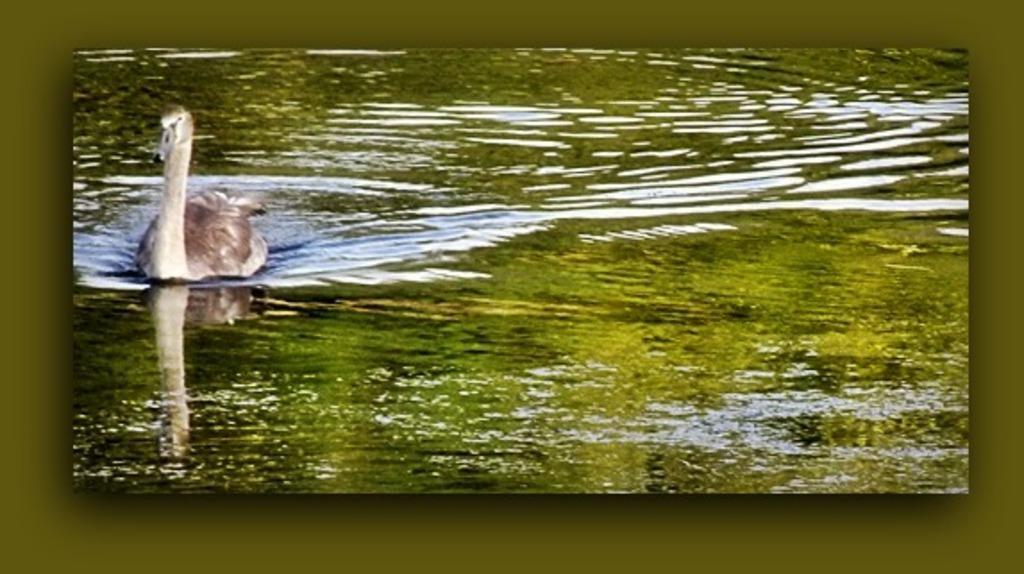How would you summarize this image in a sentence or two? This is an edited image. In the image we can see a swan in the water. 